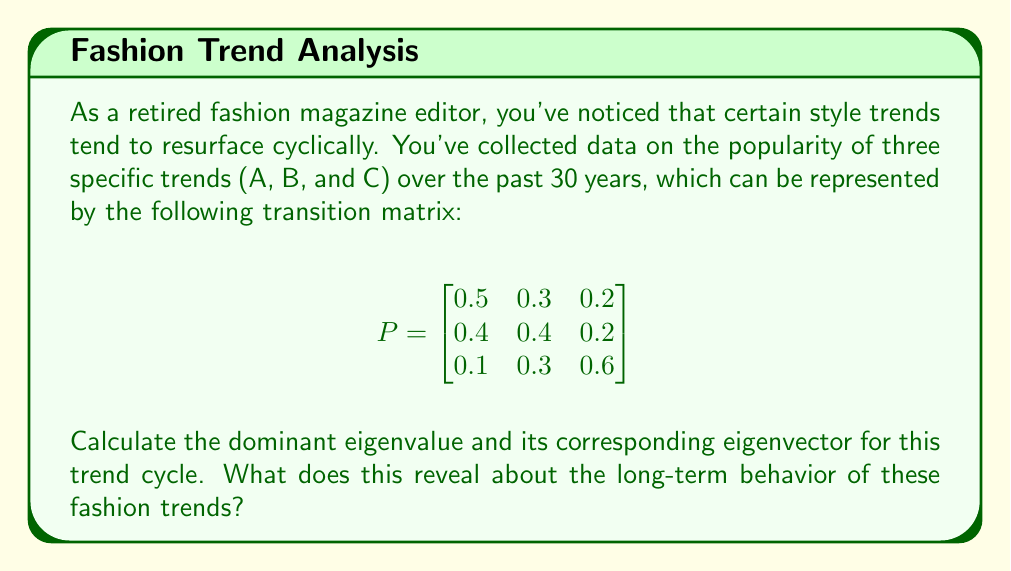Give your solution to this math problem. 1. To find the eigenvalues, we solve the characteristic equation:
   $$det(P - \lambda I) = 0$$

2. Expanding the determinant:
   $$\begin{vmatrix}
   0.5 - \lambda & 0.3 & 0.2 \\
   0.4 & 0.4 - \lambda & 0.2 \\
   0.1 & 0.3 & 0.6 - \lambda
   \end{vmatrix} = 0$$

3. This yields the cubic equation:
   $$-\lambda^3 + 1.5\lambda^2 - 0.47\lambda + 0.036 = 0$$

4. Solving this equation (using a calculator or computer algebra system) gives us the eigenvalues:
   $$\lambda_1 \approx 1, \lambda_2 \approx 0.3791, \lambda_3 \approx 0.1209$$

5. The dominant eigenvalue is $\lambda_1 = 1$.

6. To find the corresponding eigenvector $\vec{v}$, we solve:
   $$(P - I)\vec{v} = \vec{0}$$

7. This gives us the system of equations:
   $$\begin{cases}
   -0.5v_1 + 0.3v_2 + 0.2v_3 = 0 \\
   0.4v_1 - 0.6v_2 + 0.2v_3 = 0 \\
   0.1v_1 + 0.3v_2 - 0.4v_3 = 0
   \end{cases}$$

8. Solving this system (and normalizing), we get the eigenvector:
   $$\vec{v} \approx \begin{bmatrix} 0.4286 \\ 0.4286 \\ 0.1429 \end{bmatrix}$$

9. This eigenvector represents the steady-state distribution of the trend cycles. It indicates that in the long run, trends A and B will each be popular about 42.86% of the time, while trend C will be popular about 14.29% of the time.
Answer: Dominant eigenvalue: 1; Corresponding eigenvector: $[0.4286, 0.4286, 0.1429]^T$. This reveals that trends A and B will dominate equally in the long-term, while trend C will be less prevalent. 